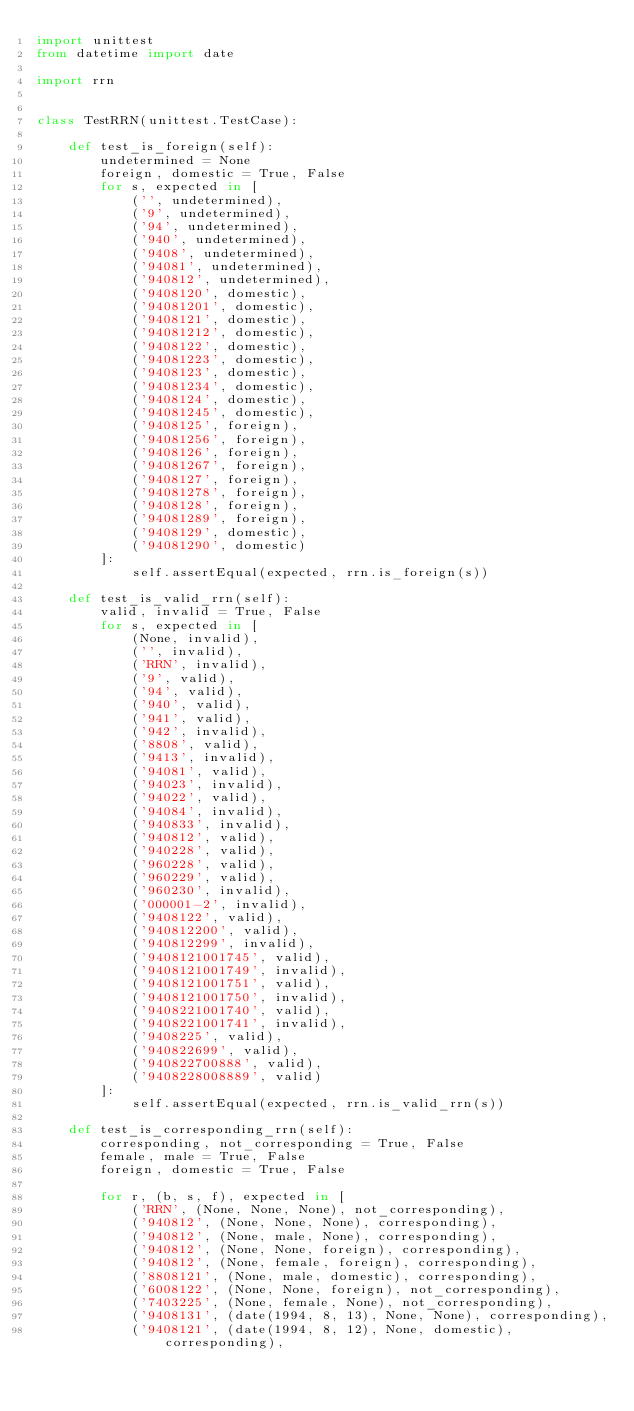<code> <loc_0><loc_0><loc_500><loc_500><_Python_>import unittest
from datetime import date

import rrn


class TestRRN(unittest.TestCase):

    def test_is_foreign(self):
        undetermined = None
        foreign, domestic = True, False
        for s, expected in [
            ('', undetermined),
            ('9', undetermined),
            ('94', undetermined),
            ('940', undetermined),
            ('9408', undetermined),
            ('94081', undetermined),
            ('940812', undetermined),
            ('9408120', domestic),
            ('94081201', domestic),
            ('9408121', domestic),
            ('94081212', domestic),
            ('9408122', domestic),
            ('94081223', domestic),
            ('9408123', domestic),
            ('94081234', domestic),
            ('9408124', domestic),
            ('94081245', domestic),
            ('9408125', foreign),
            ('94081256', foreign),
            ('9408126', foreign),
            ('94081267', foreign),
            ('9408127', foreign),
            ('94081278', foreign),
            ('9408128', foreign),
            ('94081289', foreign),
            ('9408129', domestic),
            ('94081290', domestic)
        ]:
            self.assertEqual(expected, rrn.is_foreign(s))

    def test_is_valid_rrn(self):
        valid, invalid = True, False
        for s, expected in [
            (None, invalid),
            ('', invalid),
            ('RRN', invalid),
            ('9', valid),
            ('94', valid),
            ('940', valid),
            ('941', valid),
            ('942', invalid),
            ('8808', valid),
            ('9413', invalid),
            ('94081', valid),
            ('94023', invalid),
            ('94022', valid),
            ('94084', invalid),
            ('940833', invalid),
            ('940812', valid),
            ('940228', valid),
            ('960228', valid),
            ('960229', valid),
            ('960230', invalid),
            ('000001-2', invalid),
            ('9408122', valid),
            ('940812200', valid),
            ('940812299', invalid),
            ('9408121001745', valid),
            ('9408121001749', invalid),
            ('9408121001751', valid),
            ('9408121001750', invalid),
            ('9408221001740', valid),
            ('9408221001741', invalid),
            ('9408225', valid),
            ('940822699', valid),
            ('940822700888', valid),
            ('9408228008889', valid)
        ]:
            self.assertEqual(expected, rrn.is_valid_rrn(s))

    def test_is_corresponding_rrn(self):
        corresponding, not_corresponding = True, False
        female, male = True, False
        foreign, domestic = True, False

        for r, (b, s, f), expected in [
            ('RRN', (None, None, None), not_corresponding),
            ('940812', (None, None, None), corresponding),
            ('940812', (None, male, None), corresponding),
            ('940812', (None, None, foreign), corresponding),
            ('940812', (None, female, foreign), corresponding),
            ('8808121', (None, male, domestic), corresponding),
            ('6008122', (None, None, foreign), not_corresponding),
            ('7403225', (None, female, None), not_corresponding),
            ('9408131', (date(1994, 8, 13), None, None), corresponding),
            ('9408121', (date(1994, 8, 12), None, domestic), corresponding),</code> 